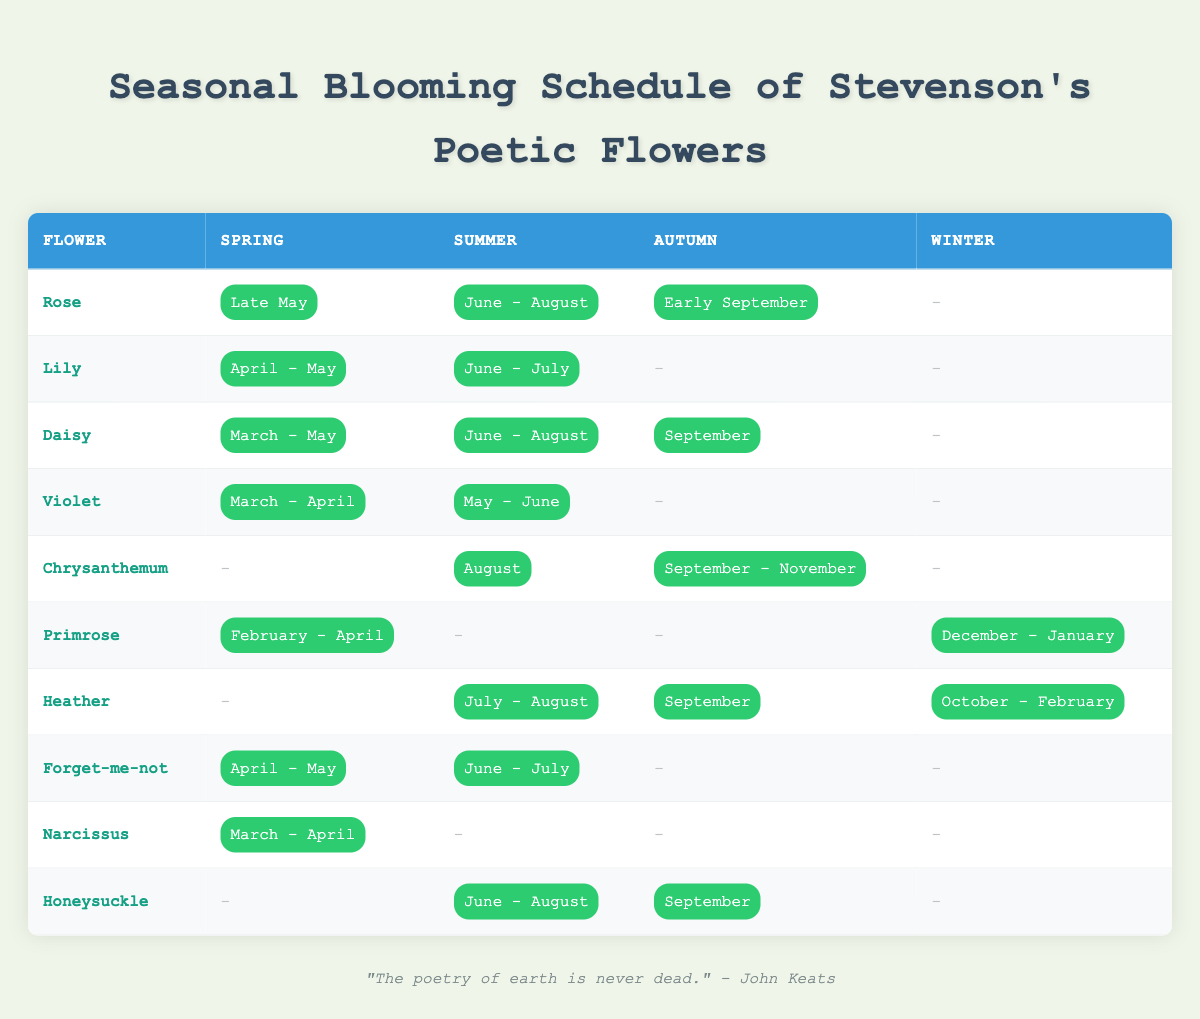What flowers bloom during the summer? To answer this, I look through the 'Summer' column of the table. The flowers that have blooming periods listed for summer are: Rose, Lily, Daisy, Violet, Chrysanthemum, Heather, Forget-me-not, and Honeysuckle.
Answer: Rose, Lily, Daisy, Violet, Chrysanthemum, Heather, Forget-me-not, Honeysuckle How many flowers bloom in spring? I count the entries in the 'Spring' column that do not have a dash. The flowers that bloom in spring are: Rose, Lily, Daisy, Violet, Primrose, Forget-me-not, and Narcissus. There are 7 flowers total.
Answer: 7 Which flower has the longest blooming period? To determine this, I need to compare the blooming periods of each flower. The daisy blooms from March to September, making it a 7-month blooming period. Other flowers like the Heather bloom for 6 months (July to February), and this makes Daisy the longest.
Answer: Daisy Does the Primrose bloom in summer? I look for the entry for Primrose under the summer column. Since it has a dash in the summer column, this means it does not bloom in the summer.
Answer: No Which flower blooms in winter? I check the 'Winter' column for flowers that have blooming periods listed. The only flower that blooms in winter is the Primrose, specifically in December to January.
Answer: Primrose What is the blooming period of the Chrysanthemum? I check the row for Chrysanthemum across all four seasons. It blooms in August during summer and from September to November in autumn.
Answer: August and September - November Which season does the Violet bloom the most? I assess the blooming periods of Violet by checking each season. It blooms in both spring (March - April) and summer (May - June) but does not bloom in autumn and winter. Counting the months, Violet blooms for 2 months in spring and 2 months in summer. It blooms for the same period in both seasons, but is more active in spring when it blooms earlier.
Answer: Spring and Summer Are there any flowers that bloom in all seasons? I examine the list of blooming periods for each flower to see if any have a blooming period listed in every season. None of the flowers are blooming throughout all seasons, so the answer is no.
Answer: No What flowers do not bloom in autumn? I check the 'Autumn' column to find flowers that have dashes. The flowers that do not bloom in autumn are: Lily, Chrysanthemum, Primrose, Narcissus, and Honeysuckle.
Answer: Lily, Chrysanthemum, Primrose, Narcissus, Honeysuckle 